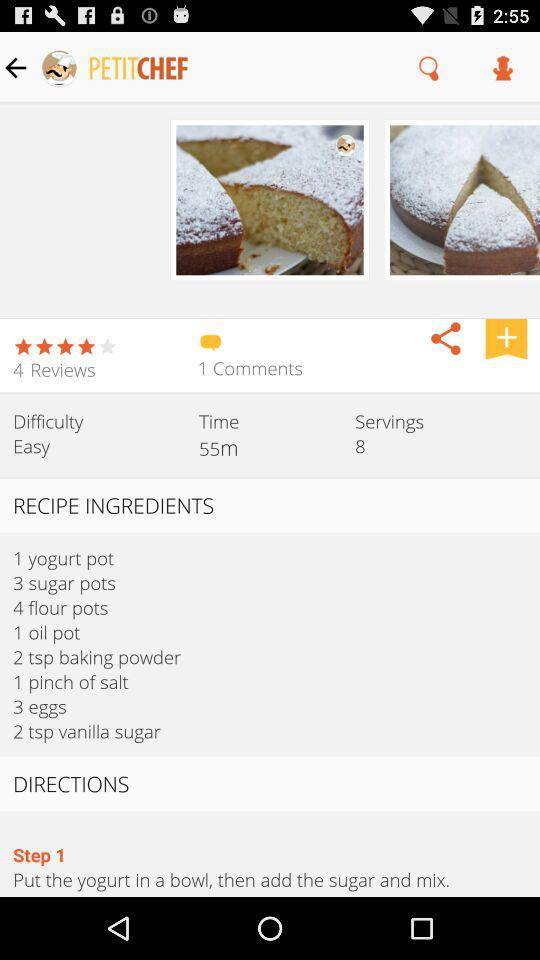What is the application name? The application name is "PETITCHEF". 